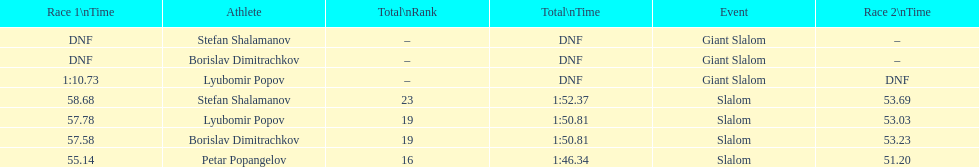What is the difference in time for petar popangelov in race 1and 2 3.94. 